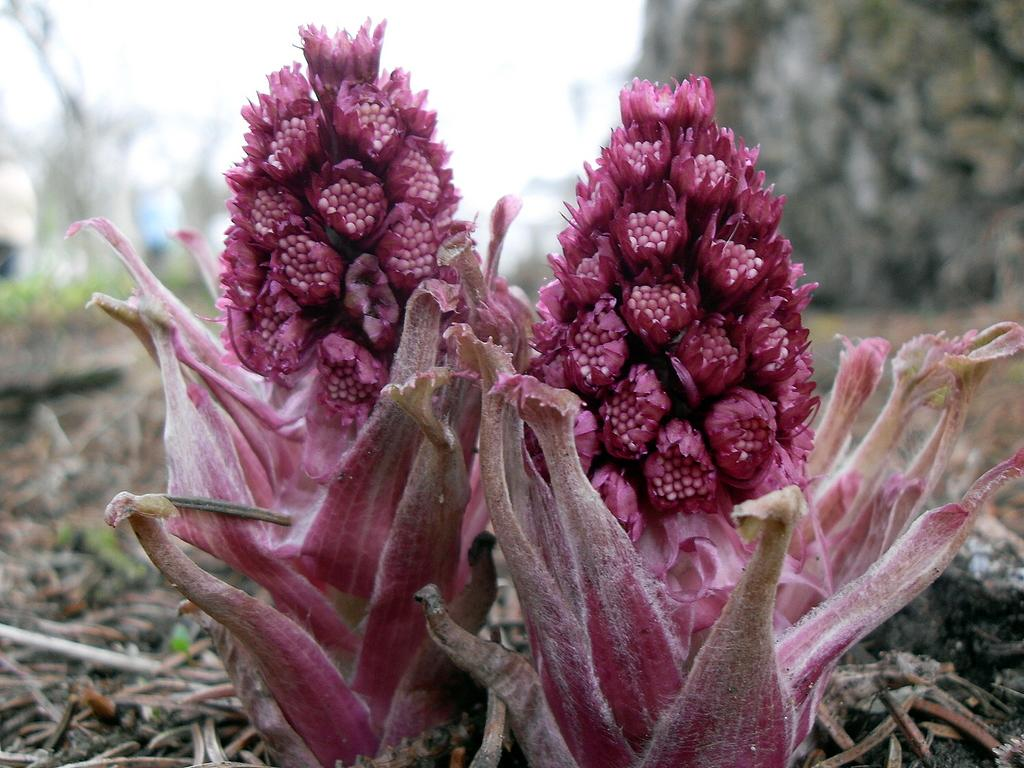What type of living organisms can be seen in the image? There are flowers on plants in the image. Can you describe the background of the image? The background of the image is blurred. What type of pen is being used by the band in the image? There is no pen or band present in the image; it features flowers on plants with a blurred background. 